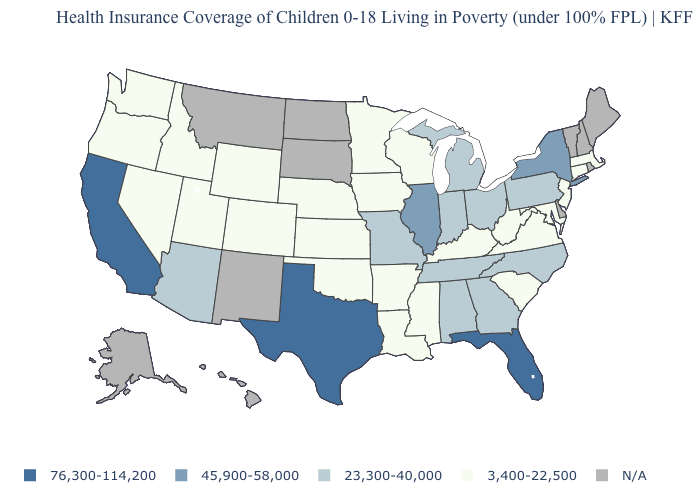Does California have the lowest value in the West?
Quick response, please. No. What is the value of Nevada?
Quick response, please. 3,400-22,500. What is the value of North Carolina?
Keep it brief. 23,300-40,000. Which states hav the highest value in the South?
Answer briefly. Florida, Texas. Which states have the highest value in the USA?
Keep it brief. California, Florida, Texas. What is the value of New Jersey?
Be succinct. 3,400-22,500. Which states have the lowest value in the USA?
Quick response, please. Arkansas, Colorado, Connecticut, Idaho, Iowa, Kansas, Kentucky, Louisiana, Maryland, Massachusetts, Minnesota, Mississippi, Nebraska, Nevada, New Jersey, Oklahoma, Oregon, South Carolina, Utah, Virginia, Washington, West Virginia, Wisconsin, Wyoming. What is the value of Pennsylvania?
Concise answer only. 23,300-40,000. What is the highest value in states that border Mississippi?
Concise answer only. 23,300-40,000. What is the highest value in states that border Kansas?
Give a very brief answer. 23,300-40,000. Name the states that have a value in the range 76,300-114,200?
Quick response, please. California, Florida, Texas. Among the states that border Nevada , does Idaho have the highest value?
Answer briefly. No. Name the states that have a value in the range N/A?
Short answer required. Alaska, Delaware, Hawaii, Maine, Montana, New Hampshire, New Mexico, North Dakota, Rhode Island, South Dakota, Vermont. What is the value of Georgia?
Quick response, please. 23,300-40,000. 